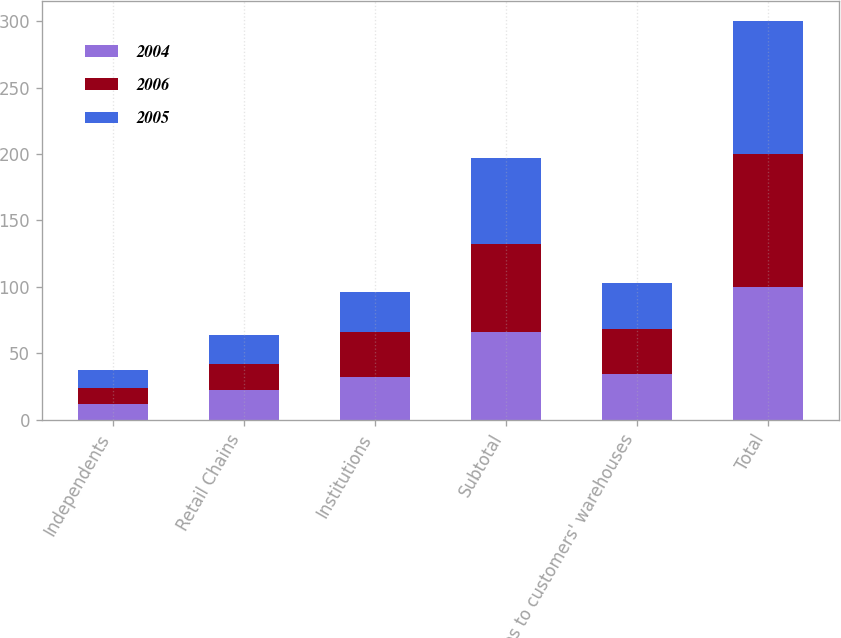Convert chart to OTSL. <chart><loc_0><loc_0><loc_500><loc_500><stacked_bar_chart><ecel><fcel>Independents<fcel>Retail Chains<fcel>Institutions<fcel>Subtotal<fcel>Sales to customers' warehouses<fcel>Total<nl><fcel>2004<fcel>12<fcel>22<fcel>32<fcel>66<fcel>34<fcel>100<nl><fcel>2006<fcel>12<fcel>20<fcel>34<fcel>66<fcel>34<fcel>100<nl><fcel>2005<fcel>13<fcel>22<fcel>30<fcel>65<fcel>35<fcel>100<nl></chart> 